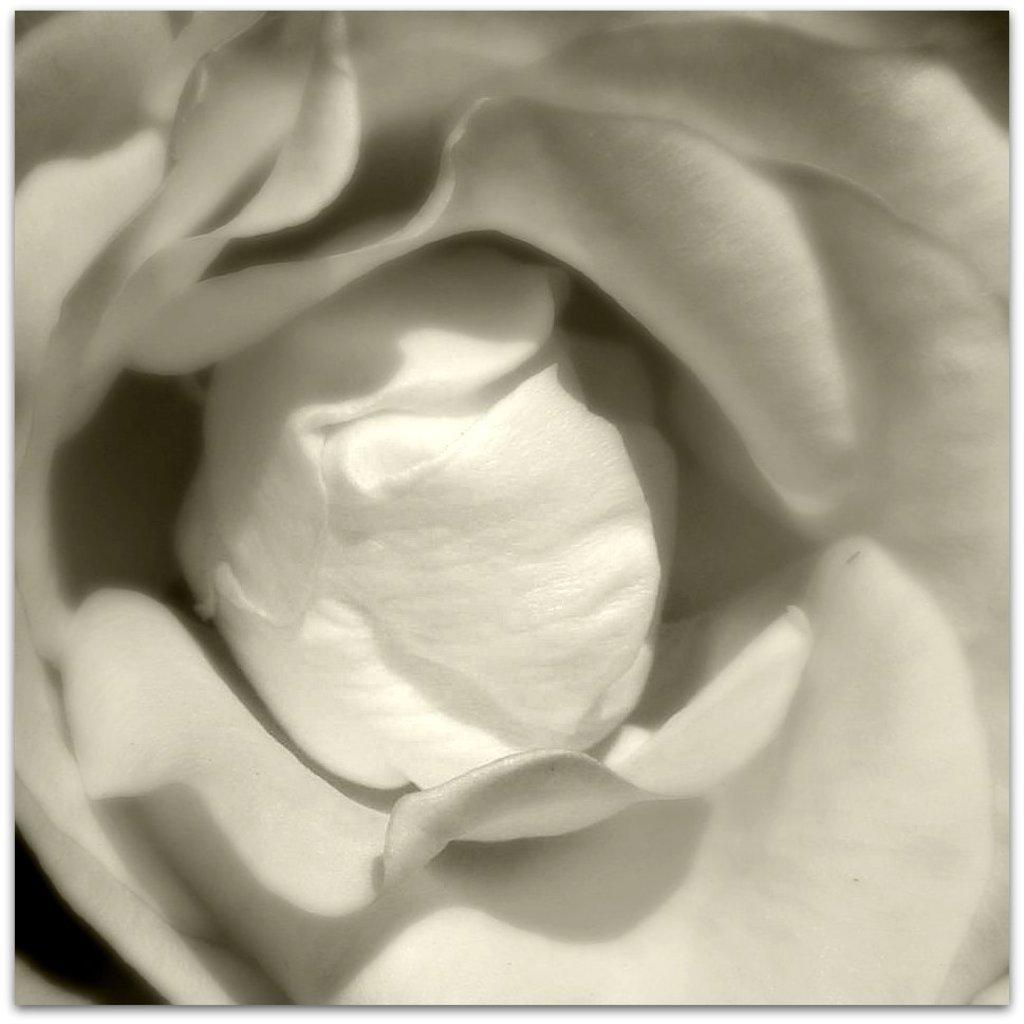Could you give a brief overview of what you see in this image? In this image we can see a flower. 